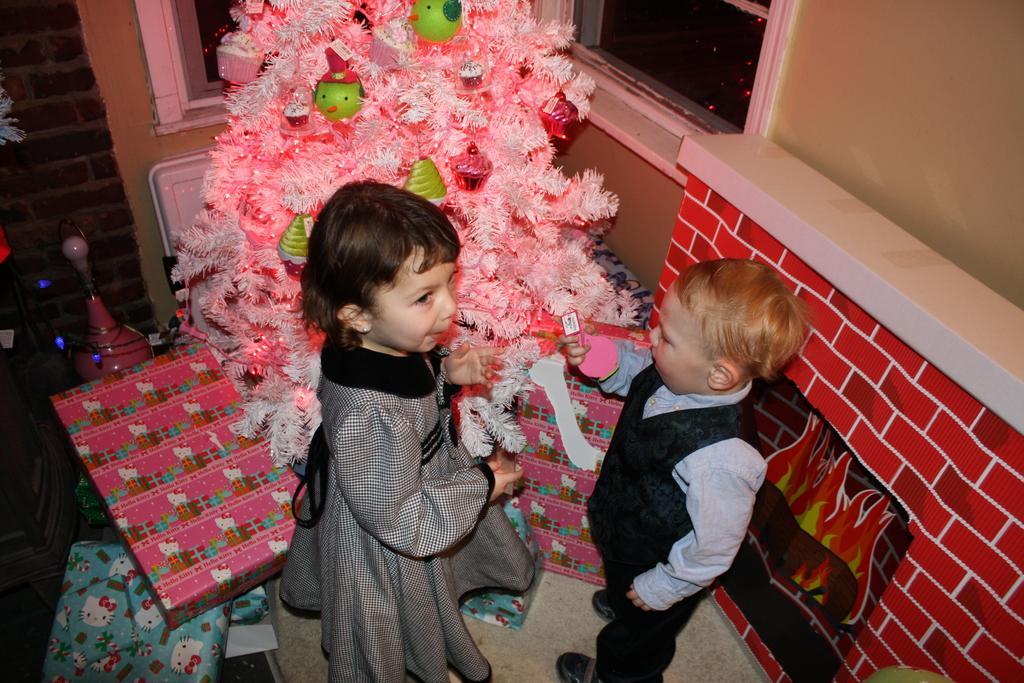How would you summarize this image in a sentence or two? In this image we can see two kids standing and holding the objects, we can see a christmas tree with lights and some objects on it, there are windows, gift boxes and the wall. 